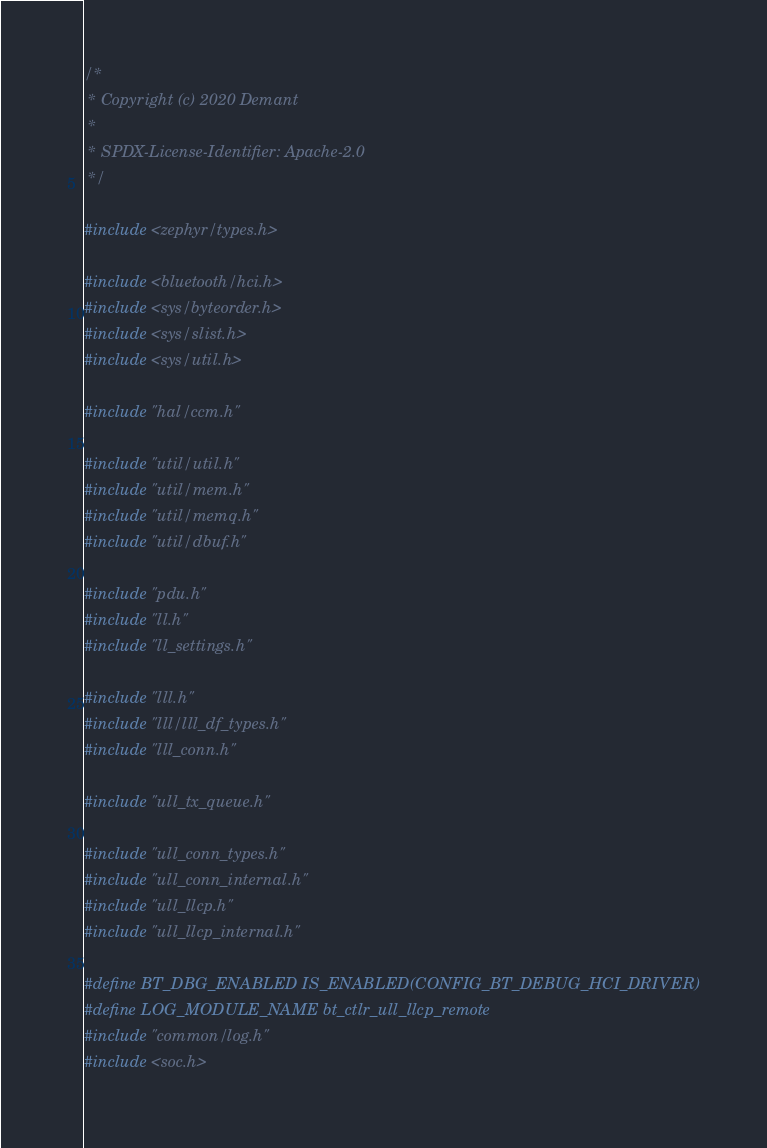<code> <loc_0><loc_0><loc_500><loc_500><_C_>/*
 * Copyright (c) 2020 Demant
 *
 * SPDX-License-Identifier: Apache-2.0
 */

#include <zephyr/types.h>

#include <bluetooth/hci.h>
#include <sys/byteorder.h>
#include <sys/slist.h>
#include <sys/util.h>

#include "hal/ccm.h"

#include "util/util.h"
#include "util/mem.h"
#include "util/memq.h"
#include "util/dbuf.h"

#include "pdu.h"
#include "ll.h"
#include "ll_settings.h"

#include "lll.h"
#include "lll/lll_df_types.h"
#include "lll_conn.h"

#include "ull_tx_queue.h"

#include "ull_conn_types.h"
#include "ull_conn_internal.h"
#include "ull_llcp.h"
#include "ull_llcp_internal.h"

#define BT_DBG_ENABLED IS_ENABLED(CONFIG_BT_DEBUG_HCI_DRIVER)
#define LOG_MODULE_NAME bt_ctlr_ull_llcp_remote
#include "common/log.h"
#include <soc.h></code> 